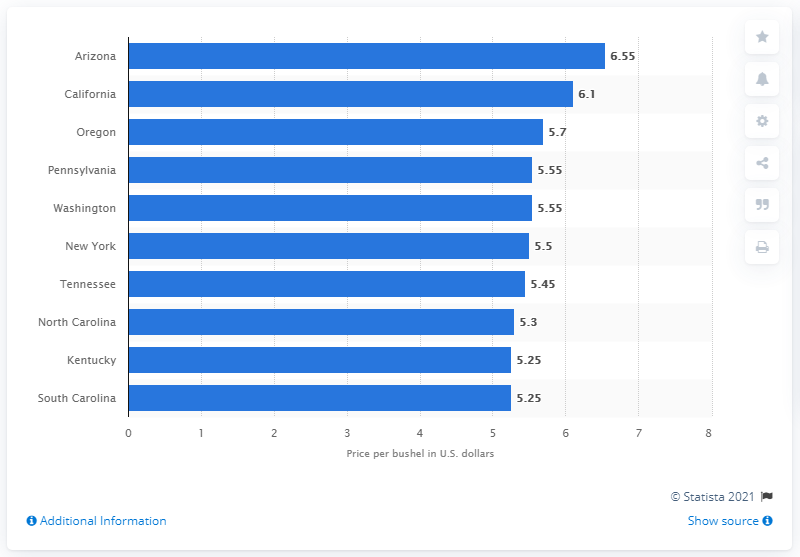Indicate a few pertinent items in this graphic. The average price per bushel of wheat in Arizona was 6.55. 